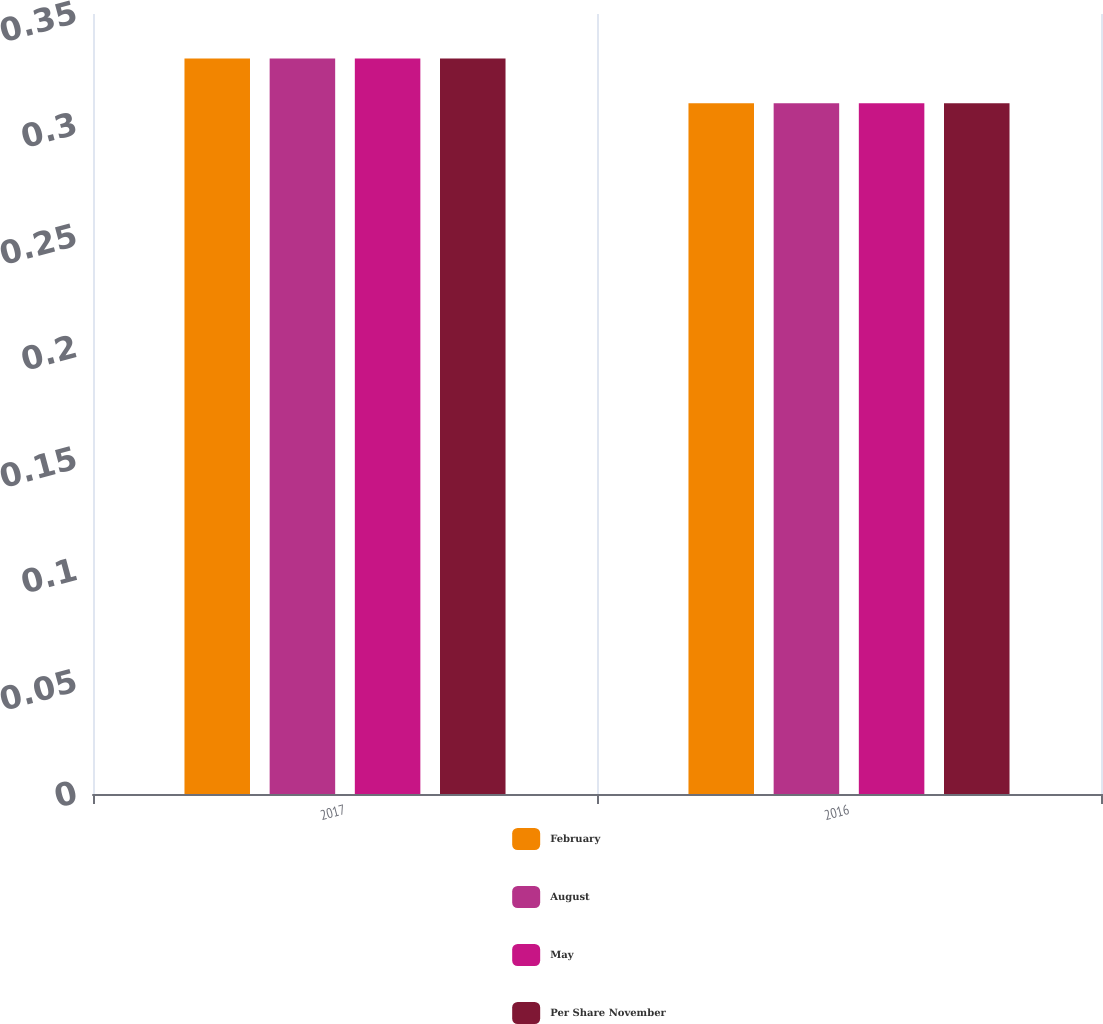Convert chart. <chart><loc_0><loc_0><loc_500><loc_500><stacked_bar_chart><ecel><fcel>2017<fcel>2016<nl><fcel>February<fcel>0.33<fcel>0.31<nl><fcel>August<fcel>0.33<fcel>0.31<nl><fcel>May<fcel>0.33<fcel>0.31<nl><fcel>Per Share November<fcel>0.33<fcel>0.31<nl></chart> 